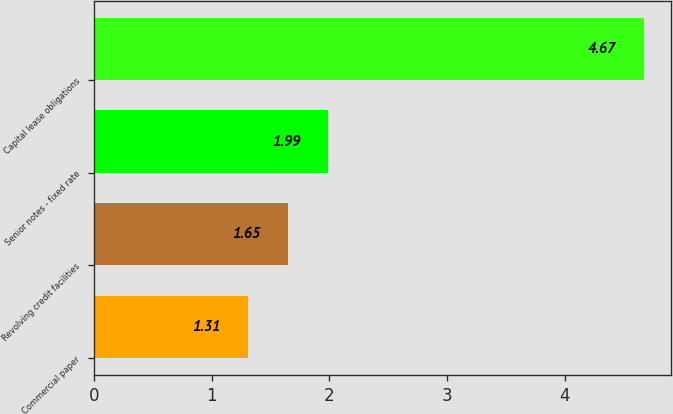Convert chart. <chart><loc_0><loc_0><loc_500><loc_500><bar_chart><fcel>Commercial paper<fcel>Revolving credit facilities<fcel>Senior notes - fixed rate<fcel>Capital lease obligations<nl><fcel>1.31<fcel>1.65<fcel>1.99<fcel>4.67<nl></chart> 